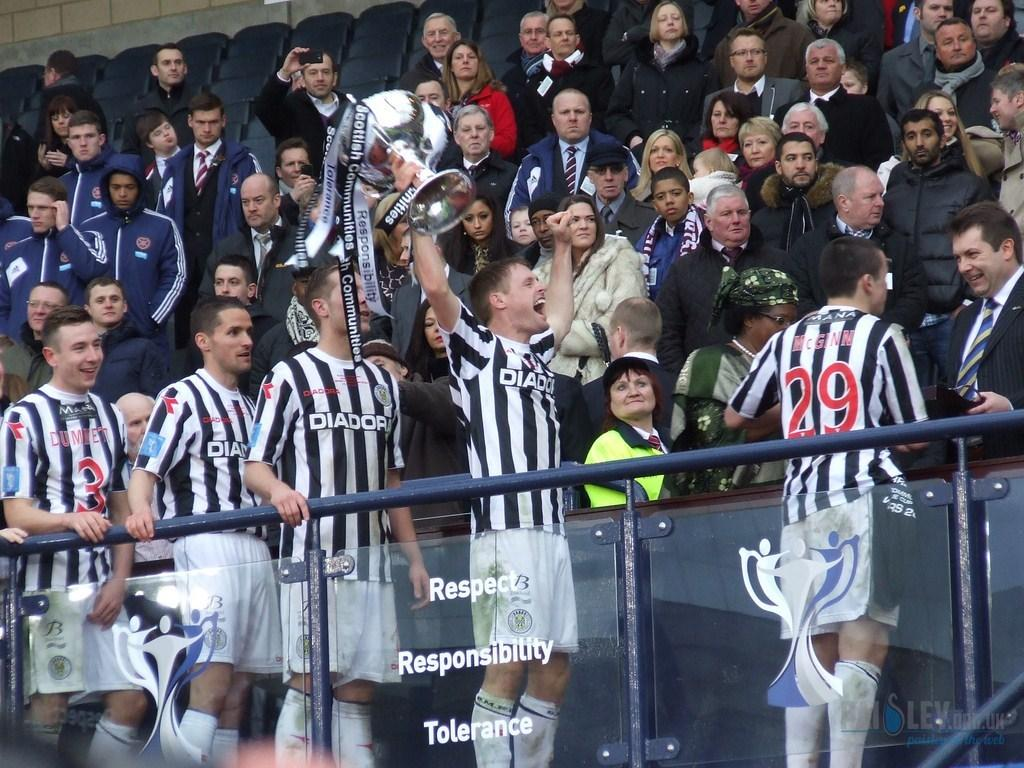<image>
Relay a brief, clear account of the picture shown. Several athletes are seen in front of a crowd, all wearing Diadora jerseys. 